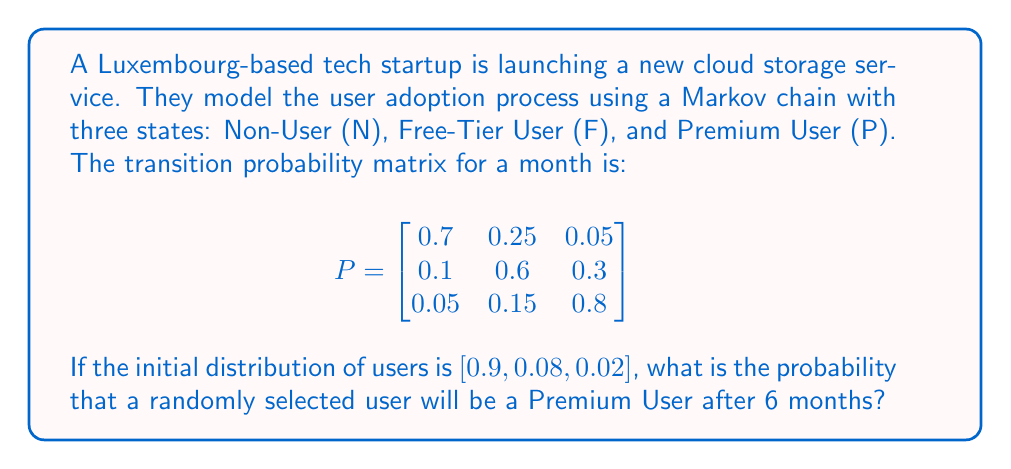Help me with this question. To solve this problem, we need to use the properties of Markov chains and matrix multiplication. Let's break it down step by step:

1) The initial distribution is given as $\pi_0 = [0.9, 0.08, 0.02]$.

2) We need to find $\pi_6$, which is the distribution after 6 months. This can be calculated using:

   $\pi_6 = \pi_0 \cdot P^6$

3) To calculate $P^6$, we need to multiply the matrix P by itself 6 times. This can be done efficiently using the power method:

   $P^2 = P \cdot P$
   $P^4 = P^2 \cdot P^2$
   $P^6 = P^4 \cdot P^2$

4) Let's calculate $P^2$:

   $$
   P^2 = \begin{bmatrix}
   0.515 & 0.3375 & 0.1475 \\
   0.145 & 0.4825 & 0.3725 \\
   0.0875 & 0.2025 & 0.71
   \end{bmatrix}
   $$

5) Now $P^4$:

   $$
   P^4 = \begin{bmatrix}
   0.384125 & 0.371875 & 0.244 \\
   0.209375 & 0.3965 & 0.394125 \\
   0.146875 & 0.265625 & 0.5875
   \end{bmatrix}
   $$

6) Finally, $P^6$:

   $$
   P^6 = \begin{bmatrix}
   0.33459375 & 0.37846875 & 0.2869375 \\
   0.24353125 & 0.38234375 & 0.374125 \\
   0.1909375 & 0.30340625 & 0.50565625
   \end{bmatrix}
   $$

7) Now we can calculate $\pi_6$:

   $\pi_6 = [0.9, 0.08, 0.02] \cdot P^6$

   $= [0.321534375, 0.37305625, 0.30540938]$

8) The probability of being a Premium User after 6 months is the third element of $\pi_6$, which is approximately 0.30540938.
Answer: 0.30540938 